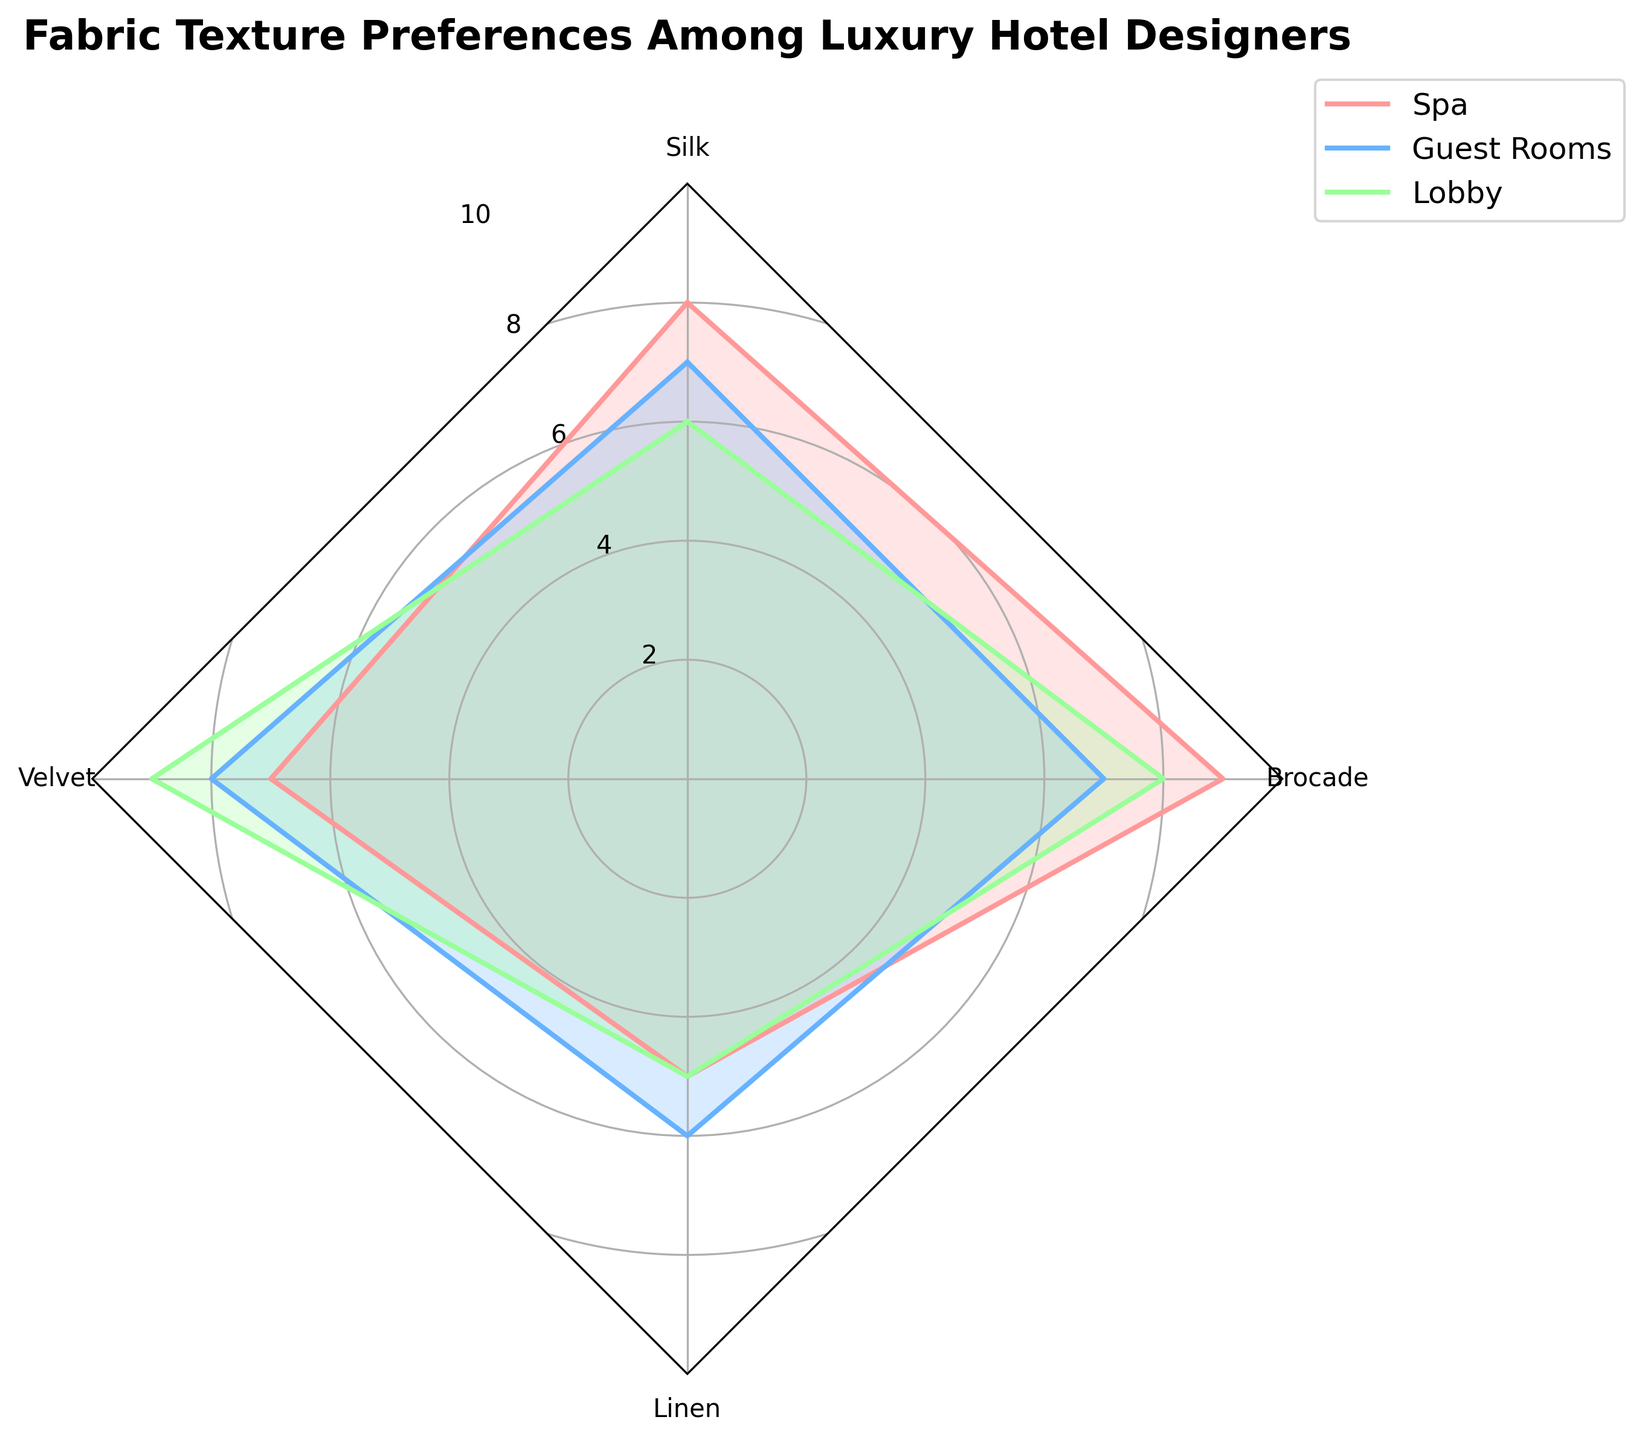What is the title of the radar chart? The title is located at the top of the radar chart, describing the content of the plot.
Answer: Fabric Texture Preferences Among Luxury Hotel Designers How many fabric textures are included in the radar chart? By counting the distinct labels on the radar chart, we can see how many fabric textures are visualized.
Answer: 4 Which fabric texture has the highest preference score in the Lobby group? By focusing on the segment labeled "Lobby" and comparing the heights of the various fabric texture scores, we can identify the highest one.
Answer: Velvet What is the difference in preference scores for Silk between the Spa and Lobby groups? The preference score for Silk in the Spa group is 8 and in the Lobby group is 6. Subtract the latter from the former to find the difference.
Answer: 2 Which fabric texture has the lowest average preference score across all groups? Calculate the average score for each fabric texture by summing its scores across Spa, Guest Rooms, and Lobby, then dividing by the number of groups (3). The fabric with the smallest average is the answer.
Answer: Linen Which group has the most varied preferences across different fabric textures? The group with the widest range (difference between the highest and lowest scores) will have the most varied preferences. Compare the ranges for Spa, Guest Rooms, and Lobby.
Answer: Spa What is the median preference score for Velvet across the Spa, Guest Rooms, and Lobby groups? The preference scores for Velvet are 7 (Spa), 8 (Guest Rooms), and 9 (Lobby). To find the median, order these scores and select the middle one.
Answer: 8 Compare the preference scores for Brocade in Spa and Guest Rooms; which is higher and by how much? Brocade's score in Spa is 9 and in Guest Rooms is 7. Subtract the latter from the former to find the difference, and indicate which is higher.
Answer: 9 is higher by 2 Looking at the Guest Rooms group, which fabric texture has the second-highest preference score? First, identify the highest score for the Guest Rooms group and then look for the second-highest score by comparing the remaining scores.
Answer: Silk (score 7) Which fabric texture shows an equal preference score in two different groups? By examining the scores, identify any fabric textures with the same value across any two groups.
Answer: Linen (score 5 in both Spa and Lobby) 